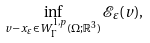<formula> <loc_0><loc_0><loc_500><loc_500>\inf _ { v - x _ { \varepsilon } \in W ^ { 1 , p } _ { \Gamma } ( \Omega ; \mathbb { R } ^ { 3 } ) } \mathcal { E } _ { \varepsilon } ( v ) ,</formula> 